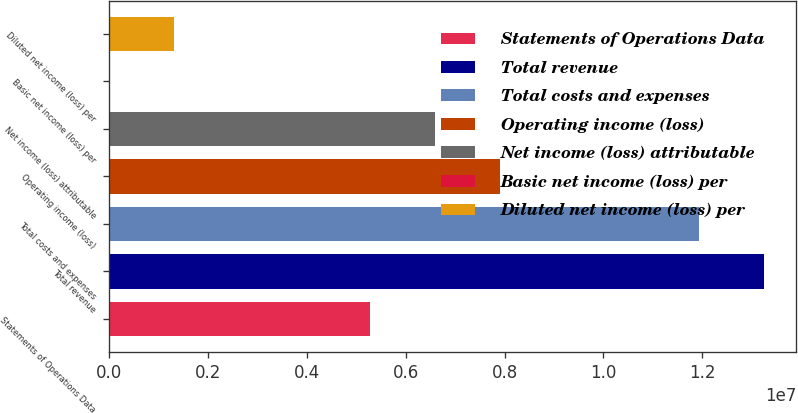<chart> <loc_0><loc_0><loc_500><loc_500><bar_chart><fcel>Statements of Operations Data<fcel>Total revenue<fcel>Total costs and expenses<fcel>Operating income (loss)<fcel>Net income (loss) attributable<fcel>Basic net income (loss) per<fcel>Diluted net income (loss) per<nl><fcel>5.27253e+06<fcel>1.32411e+07<fcel>1.1923e+07<fcel>7.9088e+06<fcel>6.59067e+06<fcel>1.41<fcel>1.31813e+06<nl></chart> 